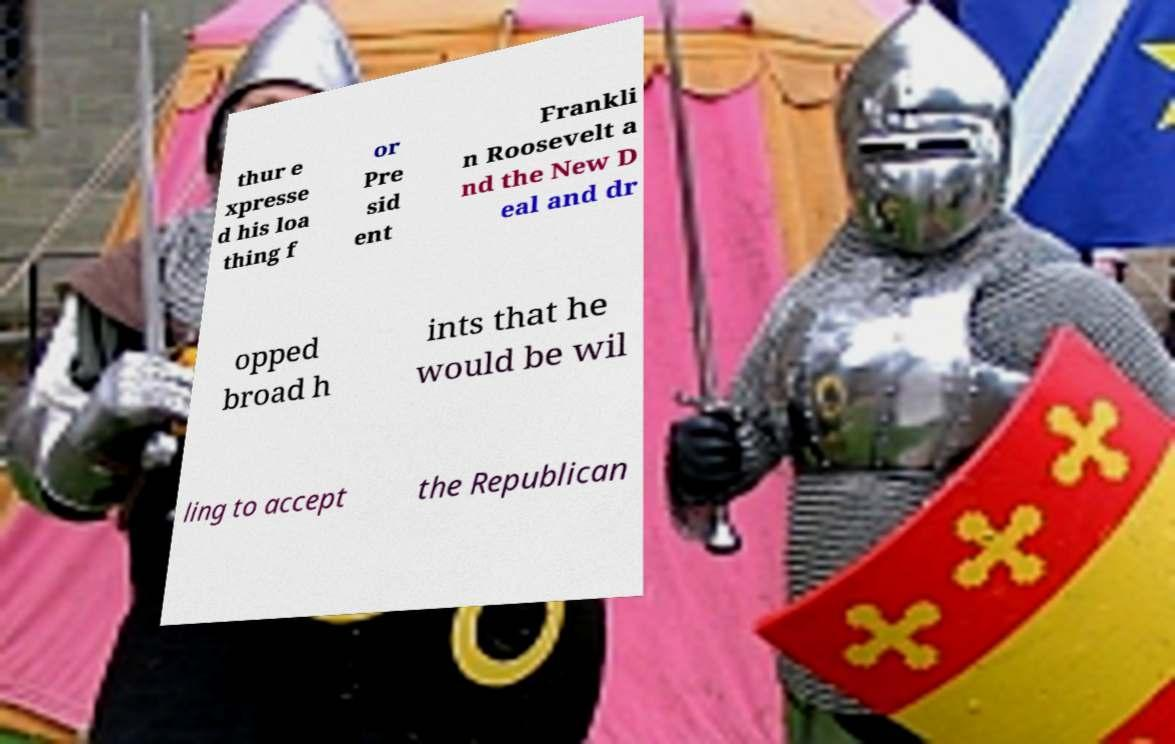Can you describe the people in the background of this image? The background shows two individuals dressed in colorful medieval attire. The person on the left appears to be wearing a helmet and a pink tunic, while the person on the right is clad in a form-fitting silver suit of armor and holds a red shield with yellow adornments. They are likely participants at a medieval reenactment event or a historical festival. 